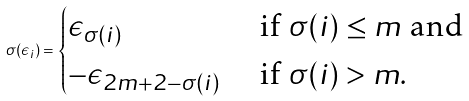<formula> <loc_0><loc_0><loc_500><loc_500>\sigma ( \epsilon _ { i } ) = \begin{cases} \epsilon _ { \sigma ( i ) } & \text { if } \sigma ( i ) \leq m \text { and} \\ - \epsilon _ { 2 m + 2 - \sigma ( i ) } & \text { if } \sigma ( i ) > m . \end{cases}</formula> 